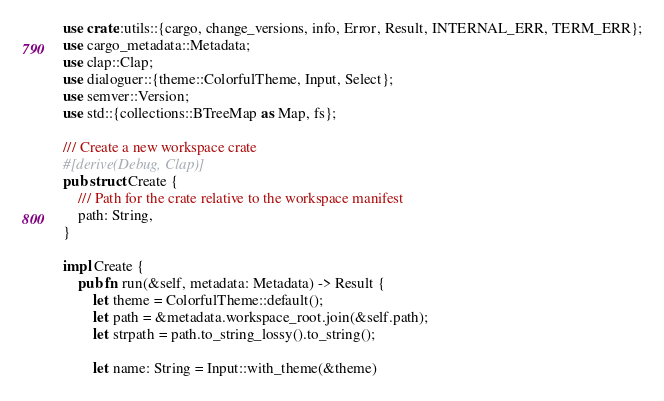<code> <loc_0><loc_0><loc_500><loc_500><_Rust_>use crate::utils::{cargo, change_versions, info, Error, Result, INTERNAL_ERR, TERM_ERR};
use cargo_metadata::Metadata;
use clap::Clap;
use dialoguer::{theme::ColorfulTheme, Input, Select};
use semver::Version;
use std::{collections::BTreeMap as Map, fs};

/// Create a new workspace crate
#[derive(Debug, Clap)]
pub struct Create {
    /// Path for the crate relative to the workspace manifest
    path: String,
}

impl Create {
    pub fn run(&self, metadata: Metadata) -> Result {
        let theme = ColorfulTheme::default();
        let path = &metadata.workspace_root.join(&self.path);
        let strpath = path.to_string_lossy().to_string();

        let name: String = Input::with_theme(&theme)</code> 